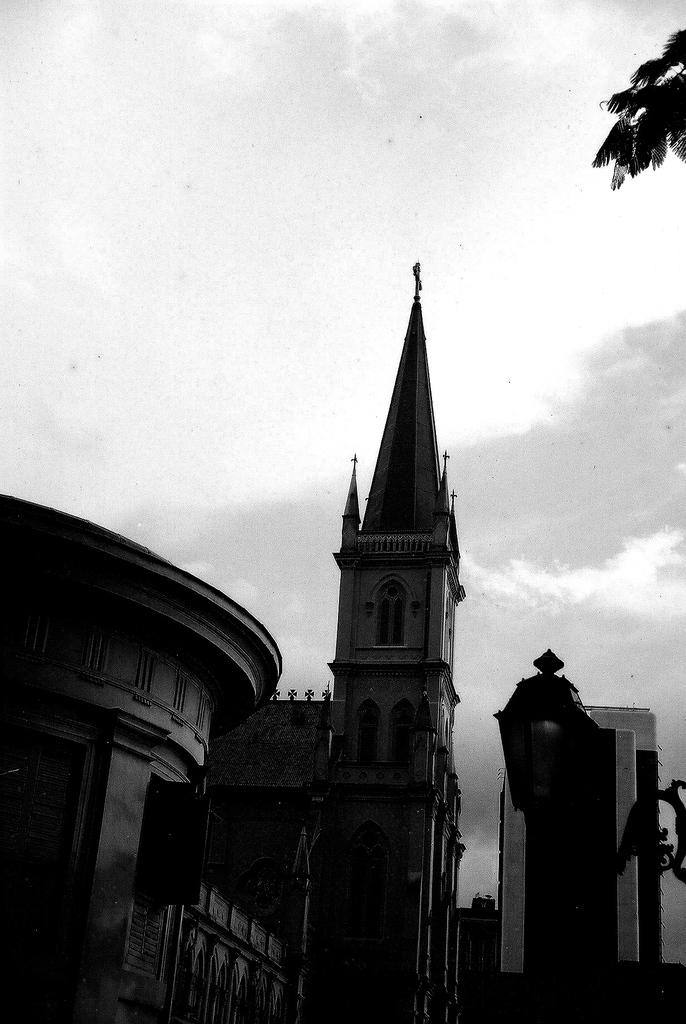What is the color scheme of the image? The image is black and white. What type of structures can be seen in the image? There are buildings in the image. What type of vegetation is present in the image? There are leaves in the image. What is visible in the background of the image? The sky is visible in the background of the image. What can be observed in the sky? Clouds are present in the sky. What type of muscle is visible in the image? There is no muscle visible in the image; it features buildings, leaves, and a sky with clouds. What type of arch can be seen in the image? There is no arch present in the image. 